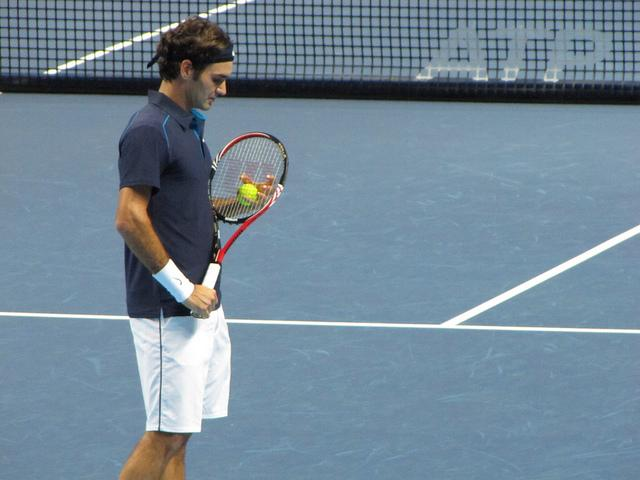What hair accessory is the player wearing to keep his hair out of his face? Please explain your reasoning. sweatband. The person is wearing a sweatband on his arm and head. 